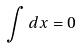<formula> <loc_0><loc_0><loc_500><loc_500>\int d x = 0</formula> 